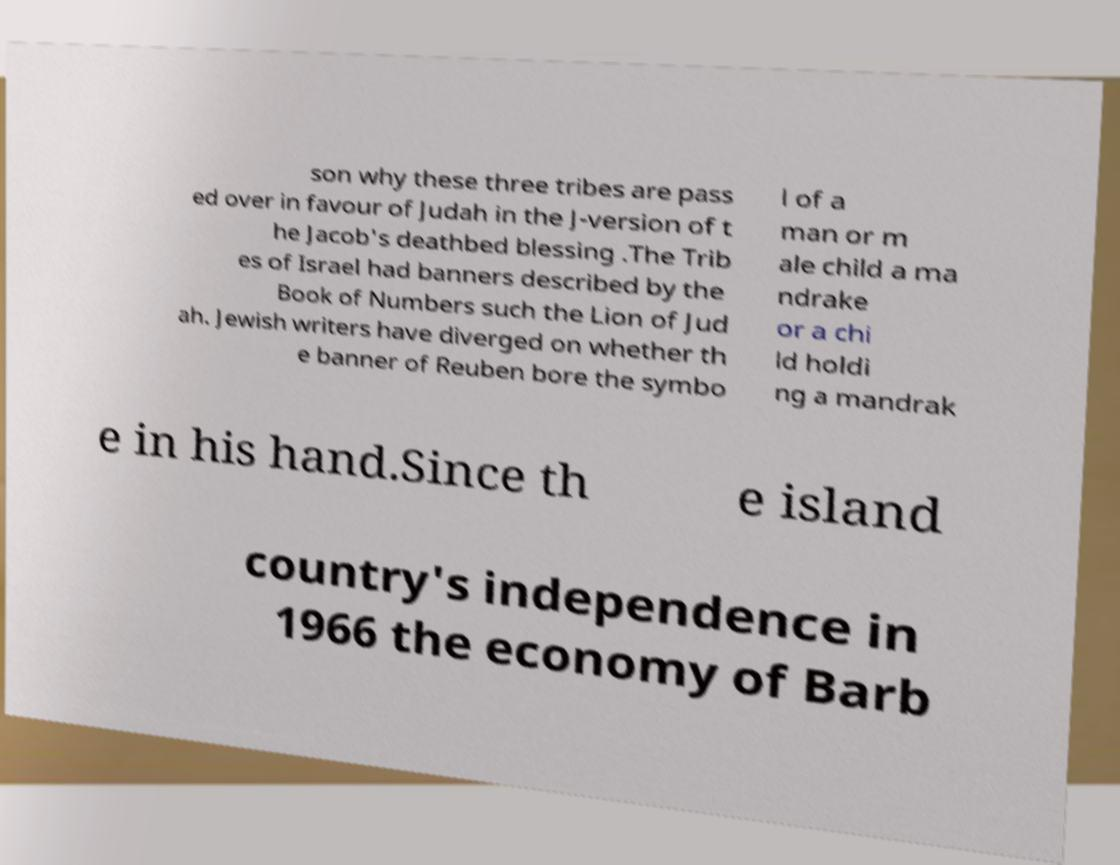Could you extract and type out the text from this image? son why these three tribes are pass ed over in favour of Judah in the J-version of t he Jacob's deathbed blessing .The Trib es of Israel had banners described by the Book of Numbers such the Lion of Jud ah. Jewish writers have diverged on whether th e banner of Reuben bore the symbo l of a man or m ale child a ma ndrake or a chi ld holdi ng a mandrak e in his hand.Since th e island country's independence in 1966 the economy of Barb 